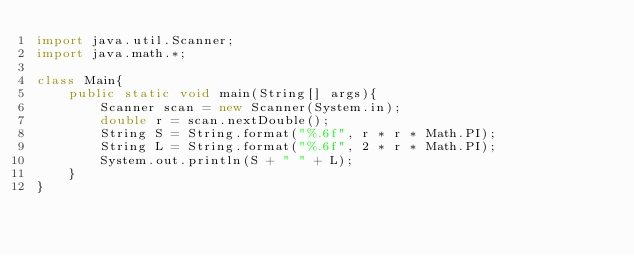Convert code to text. <code><loc_0><loc_0><loc_500><loc_500><_Java_>import java.util.Scanner;
import java.math.*;

class Main{
    public static void main(String[] args){
        Scanner scan = new Scanner(System.in);
        double r = scan.nextDouble();
        String S = String.format("%.6f", r * r * Math.PI);
        String L = String.format("%.6f", 2 * r * Math.PI);
        System.out.println(S + " " + L);
    }
}
</code> 